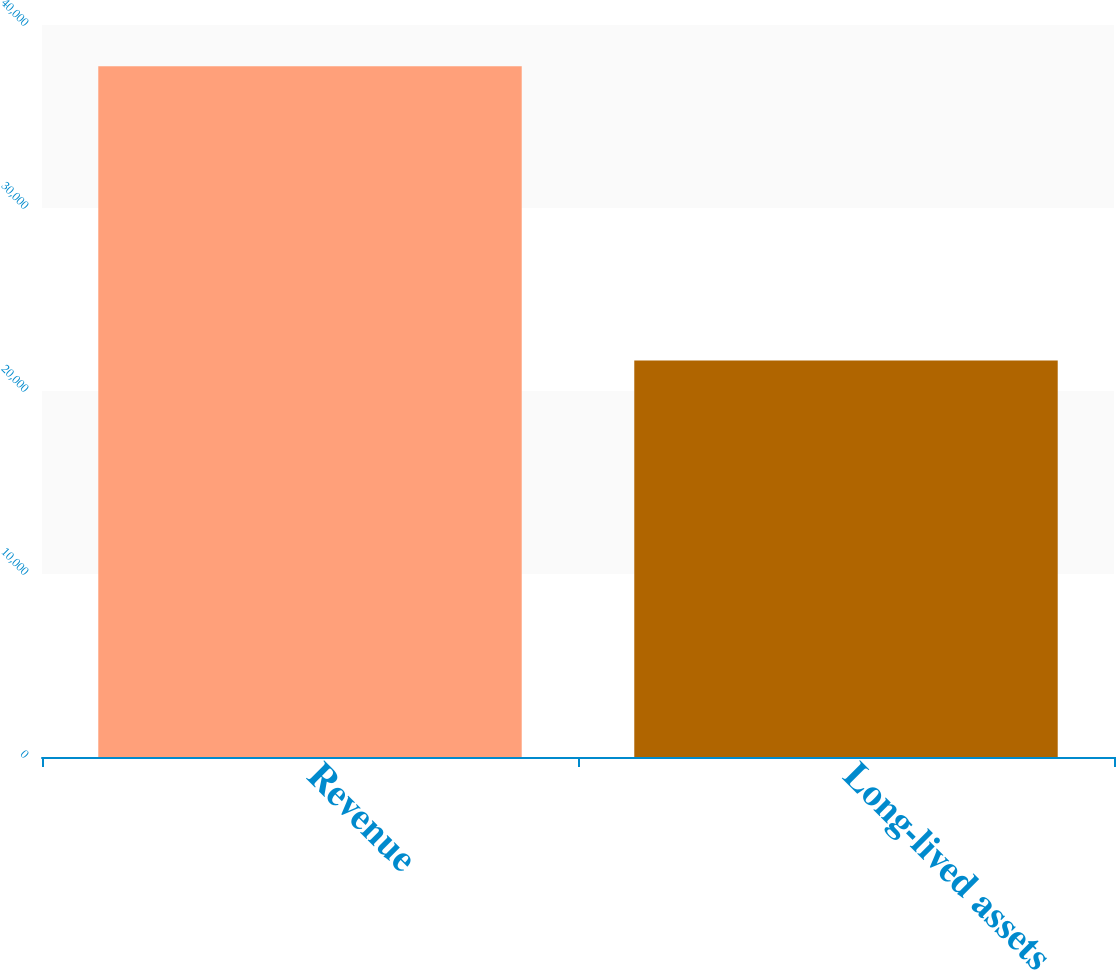<chart> <loc_0><loc_0><loc_500><loc_500><bar_chart><fcel>Revenue<fcel>Long-lived assets<nl><fcel>37741<fcel>21662<nl></chart> 